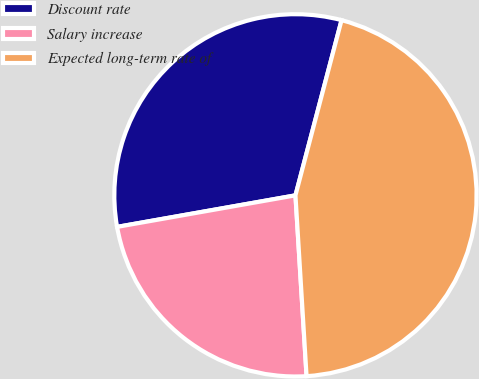Convert chart. <chart><loc_0><loc_0><loc_500><loc_500><pie_chart><fcel>Discount rate<fcel>Salary increase<fcel>Expected long-term rate of<nl><fcel>31.88%<fcel>23.19%<fcel>44.93%<nl></chart> 